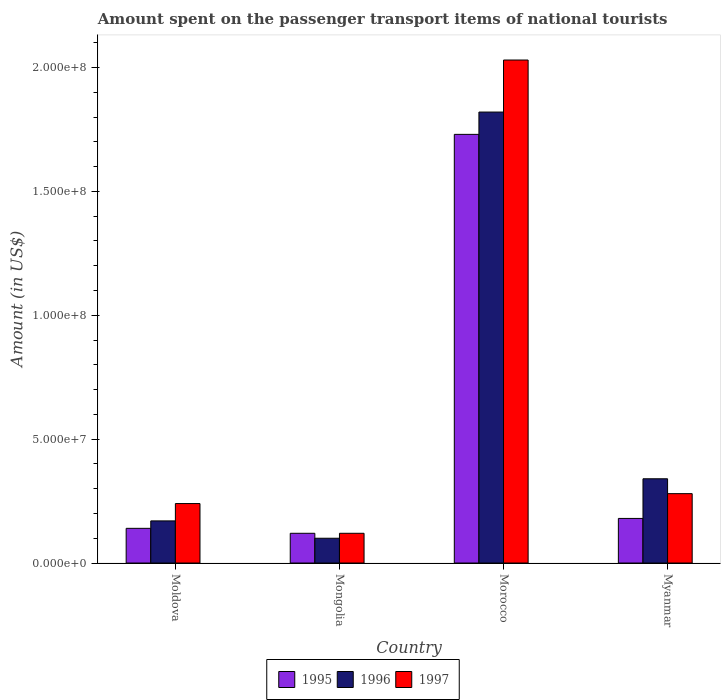How many groups of bars are there?
Provide a succinct answer. 4. Are the number of bars per tick equal to the number of legend labels?
Offer a very short reply. Yes. How many bars are there on the 4th tick from the right?
Offer a very short reply. 3. What is the label of the 3rd group of bars from the left?
Provide a succinct answer. Morocco. What is the amount spent on the passenger transport items of national tourists in 1996 in Moldova?
Your answer should be compact. 1.70e+07. Across all countries, what is the maximum amount spent on the passenger transport items of national tourists in 1996?
Your answer should be compact. 1.82e+08. In which country was the amount spent on the passenger transport items of national tourists in 1996 maximum?
Your answer should be very brief. Morocco. In which country was the amount spent on the passenger transport items of national tourists in 1995 minimum?
Keep it short and to the point. Mongolia. What is the total amount spent on the passenger transport items of national tourists in 1996 in the graph?
Provide a short and direct response. 2.43e+08. What is the difference between the amount spent on the passenger transport items of national tourists in 1995 in Morocco and the amount spent on the passenger transport items of national tourists in 1996 in Moldova?
Offer a terse response. 1.56e+08. What is the average amount spent on the passenger transport items of national tourists in 1995 per country?
Ensure brevity in your answer.  5.42e+07. What is the difference between the amount spent on the passenger transport items of national tourists of/in 1995 and amount spent on the passenger transport items of national tourists of/in 1996 in Morocco?
Your answer should be compact. -9.00e+06. In how many countries, is the amount spent on the passenger transport items of national tourists in 1997 greater than 40000000 US$?
Your answer should be compact. 1. What is the ratio of the amount spent on the passenger transport items of national tourists in 1997 in Moldova to that in Myanmar?
Provide a succinct answer. 0.86. Is the amount spent on the passenger transport items of national tourists in 1995 in Moldova less than that in Mongolia?
Your answer should be very brief. No. What is the difference between the highest and the second highest amount spent on the passenger transport items of national tourists in 1996?
Keep it short and to the point. 1.65e+08. What is the difference between the highest and the lowest amount spent on the passenger transport items of national tourists in 1995?
Offer a terse response. 1.61e+08. In how many countries, is the amount spent on the passenger transport items of national tourists in 1997 greater than the average amount spent on the passenger transport items of national tourists in 1997 taken over all countries?
Make the answer very short. 1. Is the sum of the amount spent on the passenger transport items of national tourists in 1996 in Morocco and Myanmar greater than the maximum amount spent on the passenger transport items of national tourists in 1997 across all countries?
Offer a terse response. Yes. Does the graph contain any zero values?
Your answer should be very brief. No. Where does the legend appear in the graph?
Keep it short and to the point. Bottom center. How many legend labels are there?
Keep it short and to the point. 3. How are the legend labels stacked?
Offer a very short reply. Horizontal. What is the title of the graph?
Give a very brief answer. Amount spent on the passenger transport items of national tourists. Does "1989" appear as one of the legend labels in the graph?
Offer a terse response. No. What is the label or title of the X-axis?
Offer a very short reply. Country. What is the label or title of the Y-axis?
Make the answer very short. Amount (in US$). What is the Amount (in US$) of 1995 in Moldova?
Provide a short and direct response. 1.40e+07. What is the Amount (in US$) in 1996 in Moldova?
Ensure brevity in your answer.  1.70e+07. What is the Amount (in US$) in 1997 in Moldova?
Ensure brevity in your answer.  2.40e+07. What is the Amount (in US$) of 1995 in Morocco?
Provide a succinct answer. 1.73e+08. What is the Amount (in US$) of 1996 in Morocco?
Your answer should be very brief. 1.82e+08. What is the Amount (in US$) of 1997 in Morocco?
Offer a very short reply. 2.03e+08. What is the Amount (in US$) in 1995 in Myanmar?
Make the answer very short. 1.80e+07. What is the Amount (in US$) in 1996 in Myanmar?
Give a very brief answer. 3.40e+07. What is the Amount (in US$) in 1997 in Myanmar?
Your response must be concise. 2.80e+07. Across all countries, what is the maximum Amount (in US$) of 1995?
Make the answer very short. 1.73e+08. Across all countries, what is the maximum Amount (in US$) of 1996?
Provide a short and direct response. 1.82e+08. Across all countries, what is the maximum Amount (in US$) in 1997?
Your answer should be compact. 2.03e+08. Across all countries, what is the minimum Amount (in US$) in 1995?
Make the answer very short. 1.20e+07. What is the total Amount (in US$) in 1995 in the graph?
Offer a very short reply. 2.17e+08. What is the total Amount (in US$) in 1996 in the graph?
Offer a terse response. 2.43e+08. What is the total Amount (in US$) in 1997 in the graph?
Offer a very short reply. 2.67e+08. What is the difference between the Amount (in US$) in 1996 in Moldova and that in Mongolia?
Your answer should be compact. 7.00e+06. What is the difference between the Amount (in US$) in 1995 in Moldova and that in Morocco?
Ensure brevity in your answer.  -1.59e+08. What is the difference between the Amount (in US$) of 1996 in Moldova and that in Morocco?
Provide a succinct answer. -1.65e+08. What is the difference between the Amount (in US$) in 1997 in Moldova and that in Morocco?
Provide a short and direct response. -1.79e+08. What is the difference between the Amount (in US$) in 1996 in Moldova and that in Myanmar?
Your answer should be very brief. -1.70e+07. What is the difference between the Amount (in US$) of 1995 in Mongolia and that in Morocco?
Keep it short and to the point. -1.61e+08. What is the difference between the Amount (in US$) of 1996 in Mongolia and that in Morocco?
Your response must be concise. -1.72e+08. What is the difference between the Amount (in US$) of 1997 in Mongolia and that in Morocco?
Keep it short and to the point. -1.91e+08. What is the difference between the Amount (in US$) of 1995 in Mongolia and that in Myanmar?
Your answer should be compact. -6.00e+06. What is the difference between the Amount (in US$) of 1996 in Mongolia and that in Myanmar?
Provide a short and direct response. -2.40e+07. What is the difference between the Amount (in US$) in 1997 in Mongolia and that in Myanmar?
Your response must be concise. -1.60e+07. What is the difference between the Amount (in US$) of 1995 in Morocco and that in Myanmar?
Provide a succinct answer. 1.55e+08. What is the difference between the Amount (in US$) of 1996 in Morocco and that in Myanmar?
Offer a very short reply. 1.48e+08. What is the difference between the Amount (in US$) in 1997 in Morocco and that in Myanmar?
Your answer should be very brief. 1.75e+08. What is the difference between the Amount (in US$) in 1995 in Moldova and the Amount (in US$) in 1996 in Mongolia?
Provide a short and direct response. 4.00e+06. What is the difference between the Amount (in US$) in 1995 in Moldova and the Amount (in US$) in 1996 in Morocco?
Make the answer very short. -1.68e+08. What is the difference between the Amount (in US$) of 1995 in Moldova and the Amount (in US$) of 1997 in Morocco?
Provide a succinct answer. -1.89e+08. What is the difference between the Amount (in US$) in 1996 in Moldova and the Amount (in US$) in 1997 in Morocco?
Offer a terse response. -1.86e+08. What is the difference between the Amount (in US$) in 1995 in Moldova and the Amount (in US$) in 1996 in Myanmar?
Provide a short and direct response. -2.00e+07. What is the difference between the Amount (in US$) of 1995 in Moldova and the Amount (in US$) of 1997 in Myanmar?
Give a very brief answer. -1.40e+07. What is the difference between the Amount (in US$) of 1996 in Moldova and the Amount (in US$) of 1997 in Myanmar?
Make the answer very short. -1.10e+07. What is the difference between the Amount (in US$) in 1995 in Mongolia and the Amount (in US$) in 1996 in Morocco?
Provide a succinct answer. -1.70e+08. What is the difference between the Amount (in US$) in 1995 in Mongolia and the Amount (in US$) in 1997 in Morocco?
Give a very brief answer. -1.91e+08. What is the difference between the Amount (in US$) of 1996 in Mongolia and the Amount (in US$) of 1997 in Morocco?
Give a very brief answer. -1.93e+08. What is the difference between the Amount (in US$) in 1995 in Mongolia and the Amount (in US$) in 1996 in Myanmar?
Make the answer very short. -2.20e+07. What is the difference between the Amount (in US$) in 1995 in Mongolia and the Amount (in US$) in 1997 in Myanmar?
Your response must be concise. -1.60e+07. What is the difference between the Amount (in US$) of 1996 in Mongolia and the Amount (in US$) of 1997 in Myanmar?
Give a very brief answer. -1.80e+07. What is the difference between the Amount (in US$) in 1995 in Morocco and the Amount (in US$) in 1996 in Myanmar?
Offer a terse response. 1.39e+08. What is the difference between the Amount (in US$) of 1995 in Morocco and the Amount (in US$) of 1997 in Myanmar?
Your answer should be compact. 1.45e+08. What is the difference between the Amount (in US$) in 1996 in Morocco and the Amount (in US$) in 1997 in Myanmar?
Offer a very short reply. 1.54e+08. What is the average Amount (in US$) of 1995 per country?
Your response must be concise. 5.42e+07. What is the average Amount (in US$) of 1996 per country?
Give a very brief answer. 6.08e+07. What is the average Amount (in US$) of 1997 per country?
Keep it short and to the point. 6.68e+07. What is the difference between the Amount (in US$) in 1995 and Amount (in US$) in 1997 in Moldova?
Provide a succinct answer. -1.00e+07. What is the difference between the Amount (in US$) in 1996 and Amount (in US$) in 1997 in Moldova?
Your answer should be compact. -7.00e+06. What is the difference between the Amount (in US$) of 1995 and Amount (in US$) of 1996 in Mongolia?
Your answer should be very brief. 2.00e+06. What is the difference between the Amount (in US$) of 1995 and Amount (in US$) of 1997 in Mongolia?
Ensure brevity in your answer.  0. What is the difference between the Amount (in US$) of 1996 and Amount (in US$) of 1997 in Mongolia?
Provide a succinct answer. -2.00e+06. What is the difference between the Amount (in US$) in 1995 and Amount (in US$) in 1996 in Morocco?
Ensure brevity in your answer.  -9.00e+06. What is the difference between the Amount (in US$) of 1995 and Amount (in US$) of 1997 in Morocco?
Make the answer very short. -3.00e+07. What is the difference between the Amount (in US$) of 1996 and Amount (in US$) of 1997 in Morocco?
Keep it short and to the point. -2.10e+07. What is the difference between the Amount (in US$) of 1995 and Amount (in US$) of 1996 in Myanmar?
Provide a short and direct response. -1.60e+07. What is the difference between the Amount (in US$) in 1995 and Amount (in US$) in 1997 in Myanmar?
Give a very brief answer. -1.00e+07. What is the ratio of the Amount (in US$) in 1995 in Moldova to that in Mongolia?
Make the answer very short. 1.17. What is the ratio of the Amount (in US$) of 1996 in Moldova to that in Mongolia?
Your response must be concise. 1.7. What is the ratio of the Amount (in US$) of 1995 in Moldova to that in Morocco?
Make the answer very short. 0.08. What is the ratio of the Amount (in US$) of 1996 in Moldova to that in Morocco?
Offer a very short reply. 0.09. What is the ratio of the Amount (in US$) in 1997 in Moldova to that in Morocco?
Offer a terse response. 0.12. What is the ratio of the Amount (in US$) in 1996 in Moldova to that in Myanmar?
Provide a short and direct response. 0.5. What is the ratio of the Amount (in US$) of 1995 in Mongolia to that in Morocco?
Offer a terse response. 0.07. What is the ratio of the Amount (in US$) in 1996 in Mongolia to that in Morocco?
Ensure brevity in your answer.  0.05. What is the ratio of the Amount (in US$) in 1997 in Mongolia to that in Morocco?
Offer a very short reply. 0.06. What is the ratio of the Amount (in US$) of 1996 in Mongolia to that in Myanmar?
Provide a succinct answer. 0.29. What is the ratio of the Amount (in US$) in 1997 in Mongolia to that in Myanmar?
Your response must be concise. 0.43. What is the ratio of the Amount (in US$) in 1995 in Morocco to that in Myanmar?
Your response must be concise. 9.61. What is the ratio of the Amount (in US$) in 1996 in Morocco to that in Myanmar?
Provide a short and direct response. 5.35. What is the ratio of the Amount (in US$) in 1997 in Morocco to that in Myanmar?
Provide a short and direct response. 7.25. What is the difference between the highest and the second highest Amount (in US$) of 1995?
Provide a succinct answer. 1.55e+08. What is the difference between the highest and the second highest Amount (in US$) in 1996?
Give a very brief answer. 1.48e+08. What is the difference between the highest and the second highest Amount (in US$) of 1997?
Keep it short and to the point. 1.75e+08. What is the difference between the highest and the lowest Amount (in US$) in 1995?
Your answer should be very brief. 1.61e+08. What is the difference between the highest and the lowest Amount (in US$) in 1996?
Your response must be concise. 1.72e+08. What is the difference between the highest and the lowest Amount (in US$) in 1997?
Offer a very short reply. 1.91e+08. 